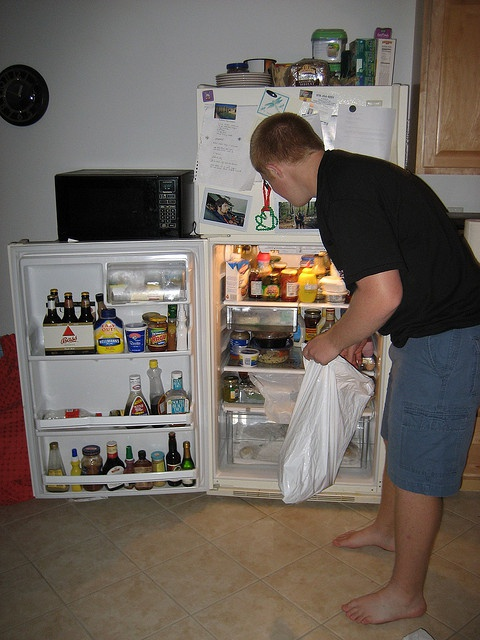Describe the objects in this image and their specific colors. I can see refrigerator in black, darkgray, and gray tones, people in black, darkblue, and brown tones, bottle in black, darkgray, gray, and olive tones, microwave in black and gray tones, and clock in black and gray tones in this image. 